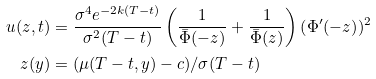<formula> <loc_0><loc_0><loc_500><loc_500>u ( z , t ) & = \frac { \sigma ^ { 4 } e ^ { - 2 k ( T - t ) } } { \sigma ^ { 2 } ( T - t ) } \left ( \frac { 1 } { \bar { \Phi } ( - z ) } + \frac { 1 } { \bar { \Phi } ( z ) } \right ) \left ( \Phi ^ { \prime } ( - z \right ) ) ^ { 2 } \, \\ z ( y ) & = ( \mu ( T - t , y ) - c ) / \sigma ( T - t )</formula> 